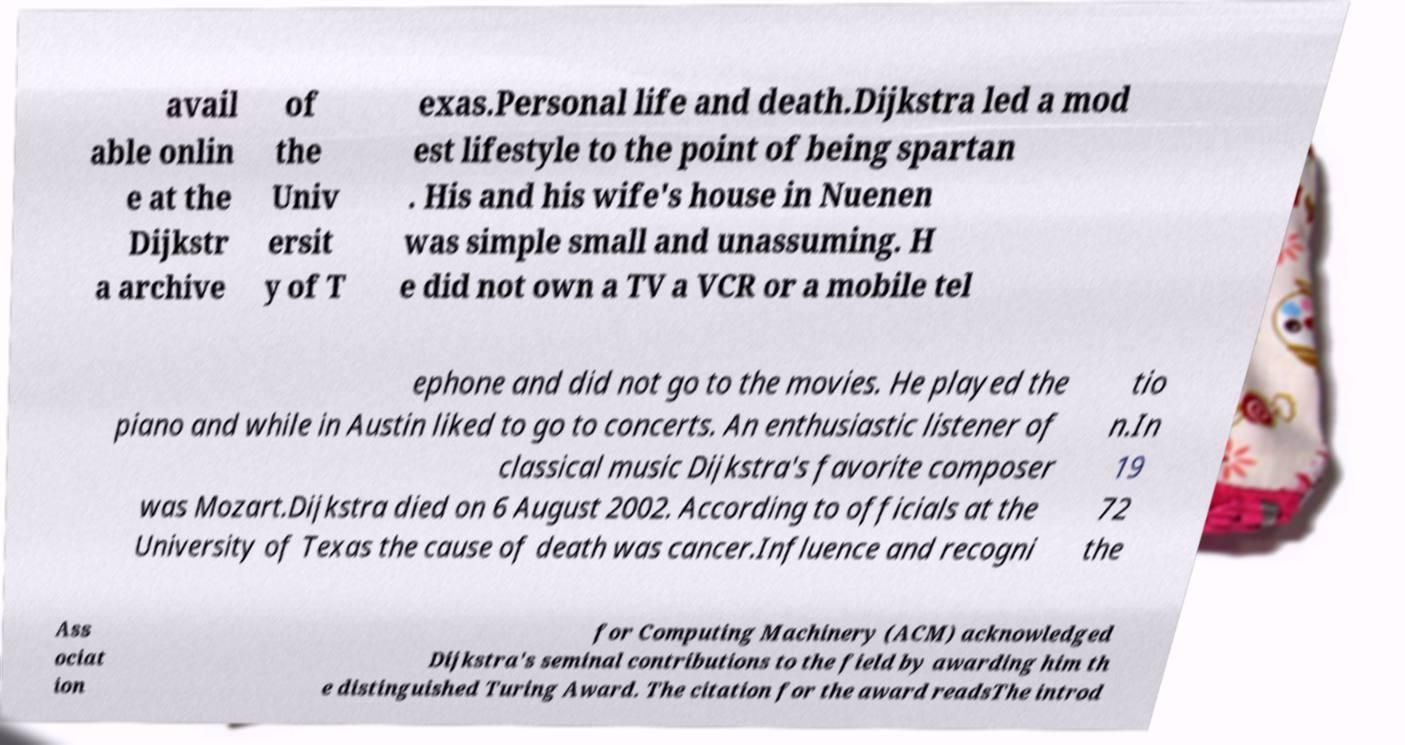I need the written content from this picture converted into text. Can you do that? avail able onlin e at the Dijkstr a archive of the Univ ersit y of T exas.Personal life and death.Dijkstra led a mod est lifestyle to the point of being spartan . His and his wife's house in Nuenen was simple small and unassuming. H e did not own a TV a VCR or a mobile tel ephone and did not go to the movies. He played the piano and while in Austin liked to go to concerts. An enthusiastic listener of classical music Dijkstra's favorite composer was Mozart.Dijkstra died on 6 August 2002. According to officials at the University of Texas the cause of death was cancer.Influence and recogni tio n.In 19 72 the Ass ociat ion for Computing Machinery (ACM) acknowledged Dijkstra's seminal contributions to the field by awarding him th e distinguished Turing Award. The citation for the award readsThe introd 